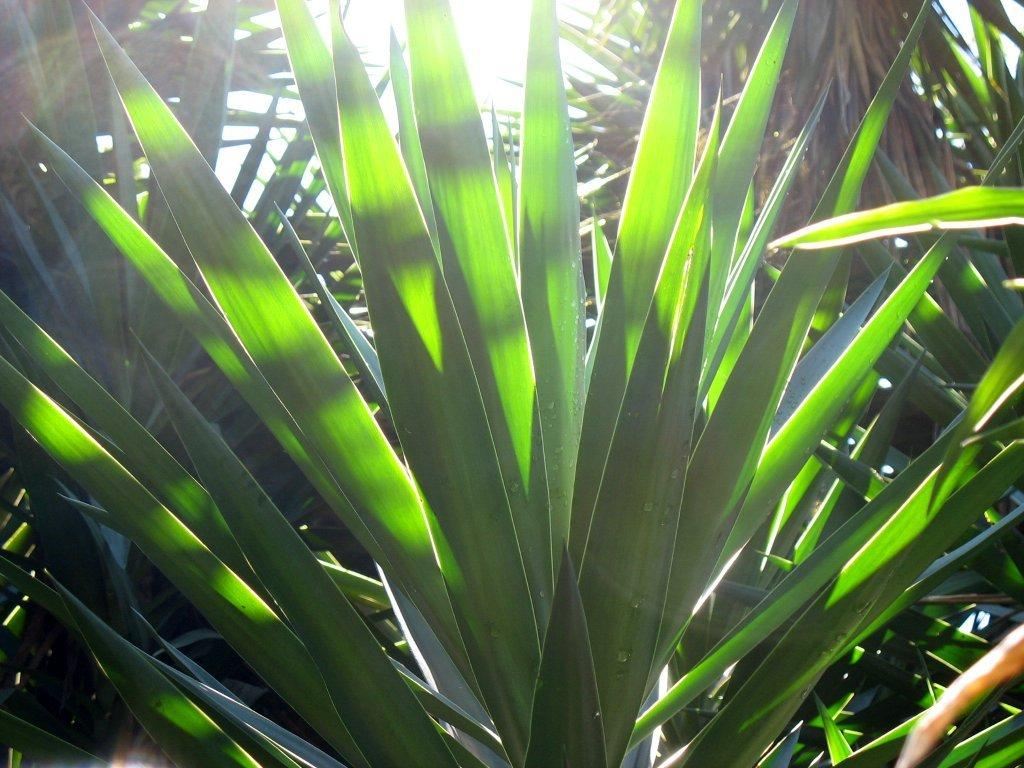What type of plants can be seen in the image? There are green plants in the image. Where are the green plants located in the image? The green plants are present throughout the image. How does the baby interact with the wind in the image? There is no baby or wind present in the image; it only features green plants. 